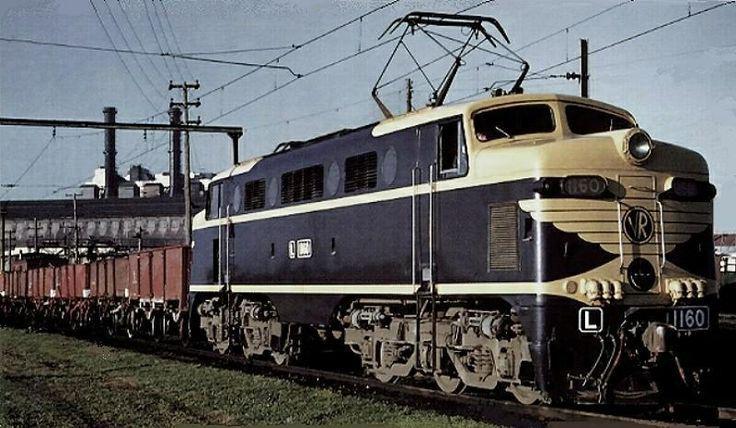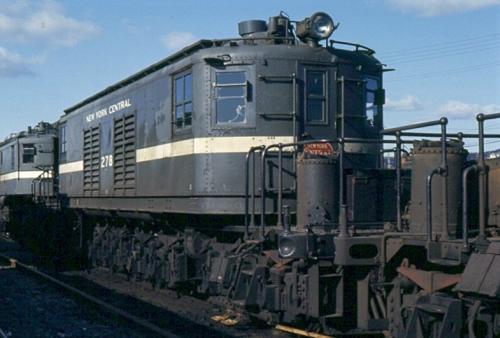The first image is the image on the left, the second image is the image on the right. Assess this claim about the two images: "There are two trains in the pair of images, both traveling slightly towards the right.". Correct or not? Answer yes or no. Yes. The first image is the image on the left, the second image is the image on the right. Assess this claim about the two images: "Each image shows one train, which is heading rightward.". Correct or not? Answer yes or no. Yes. 